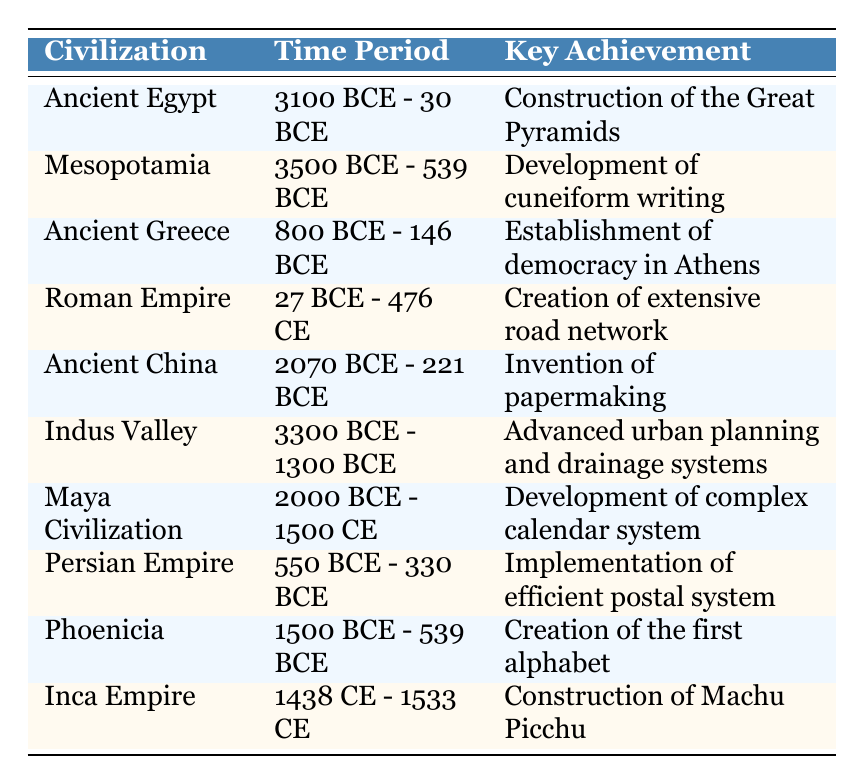What is the time period of the Roman Empire? According to the table, the Roman Empire existed from 27 BCE to 476 CE as stated in the corresponding row.
Answer: 27 BCE - 476 CE Which civilization is known for the invention of papermaking? The table indicates that Ancient China is credited with the invention of papermaking, as mentioned in the related row.
Answer: Ancient China Is the Maya Civilization the only civilization listed that thrived after 0 CE? By examining the table, we see that the Maya Civilization thrived from 2000 BCE to 1500 CE, while the Inca Empire also thrived from 1438 CE to 1533 CE. Thus, the statement is false as there are two civilizations in that time frame.
Answer: No What was the key achievement of the Indus Valley civilization? The table specifies that the key achievement of the Indus Valley civilization was advanced urban planning and drainage systems, as noted in its row.
Answer: Advanced urban planning and drainage systems Which two civilizations had time periods overlapping in the 1st millennium BCE? The civilizations of Mesopotamia (3500 BCE - 539 BCE) and the Persian Empire (550 BCE - 330 BCE) had overlapping periods, as both were active during parts of the 1st millennium BCE.
Answer: Mesopotamia and Persian Empire What is the total number of civilizations listed that made advancements in writing systems? Examining the table reveals that Mesopotamia is noted for cuneiform writing and Phoenicia created the first alphabet. This gives a total of 2 civilizations.
Answer: 2 Was the establishment of democracy in Athens achieved before the construction of the Great Pyramids? We see from the table that the Great Pyramids were constructed between 3100 BCE - 30 BCE, while the establishment of democracy in Athens occurred between 800 BCE - 146 BCE, which means the pyramids were built much earlier. So, the statement is true.
Answer: Yes Which civilization's key achievement involved a postal system? According to the table, the Persian Empire's key achievement was the implementation of an efficient postal system, as stated in the respective row.
Answer: Persian Empire Which civilization is noted for urban planning advancements along with drainage systems? The table indicates that the Indus Valley civilization is recognized for its advanced urban planning and drainage systems.
Answer: Indus Valley What difference in years exists between the earliest and latest civilizations in the table? The earliest mentioned civilization is Ancient Egypt, with a start date of 3100 BCE, and the latest is the Inca Empire, ending in 1533 CE. Calculating this gives a difference of 3100 + 2023 = 5123 years, as 2023 accounts for the years after 0 CE.
Answer: 5123 years 